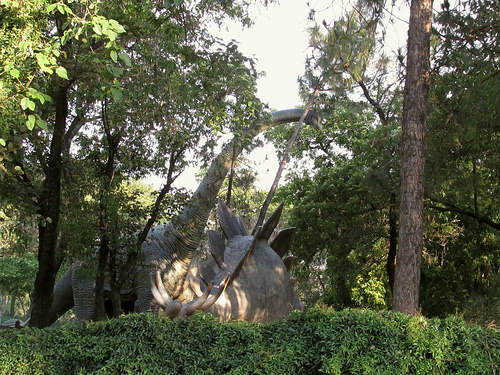<image>
Can you confirm if the dinosaur is to the left of the tree? Yes. From this viewpoint, the dinosaur is positioned to the left side relative to the tree. 